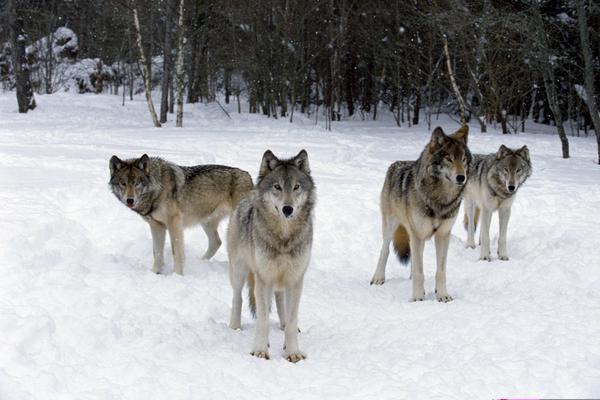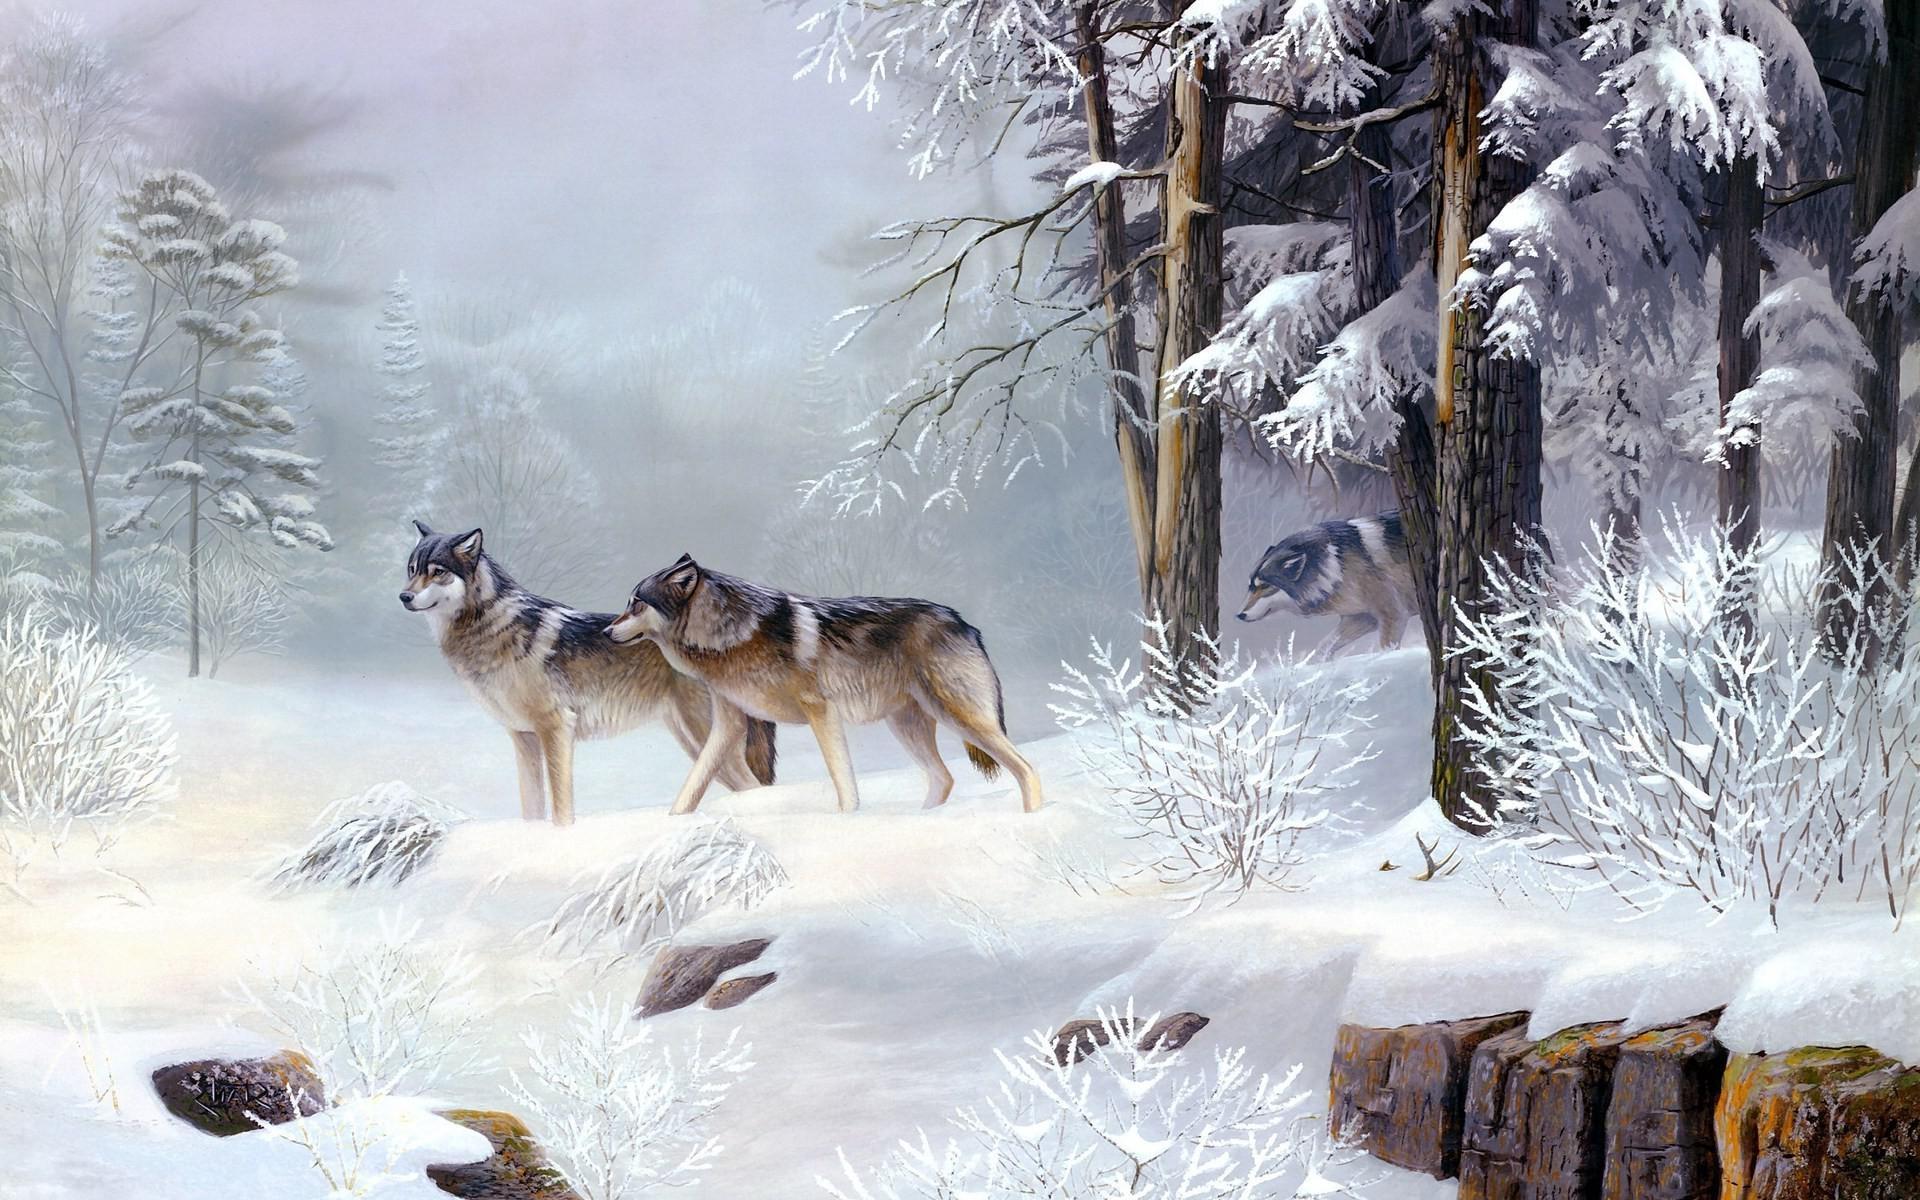The first image is the image on the left, the second image is the image on the right. For the images shown, is this caption "There is a single dog in one image and multiple dogs in the other image." true? Answer yes or no. No. The first image is the image on the left, the second image is the image on the right. Given the left and right images, does the statement "There is only one wolf in one of the images." hold true? Answer yes or no. No. 